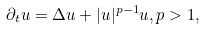Convert formula to latex. <formula><loc_0><loc_0><loc_500><loc_500>\partial _ { t } u = \Delta u + | u | ^ { p - 1 } u , p > 1 ,</formula> 